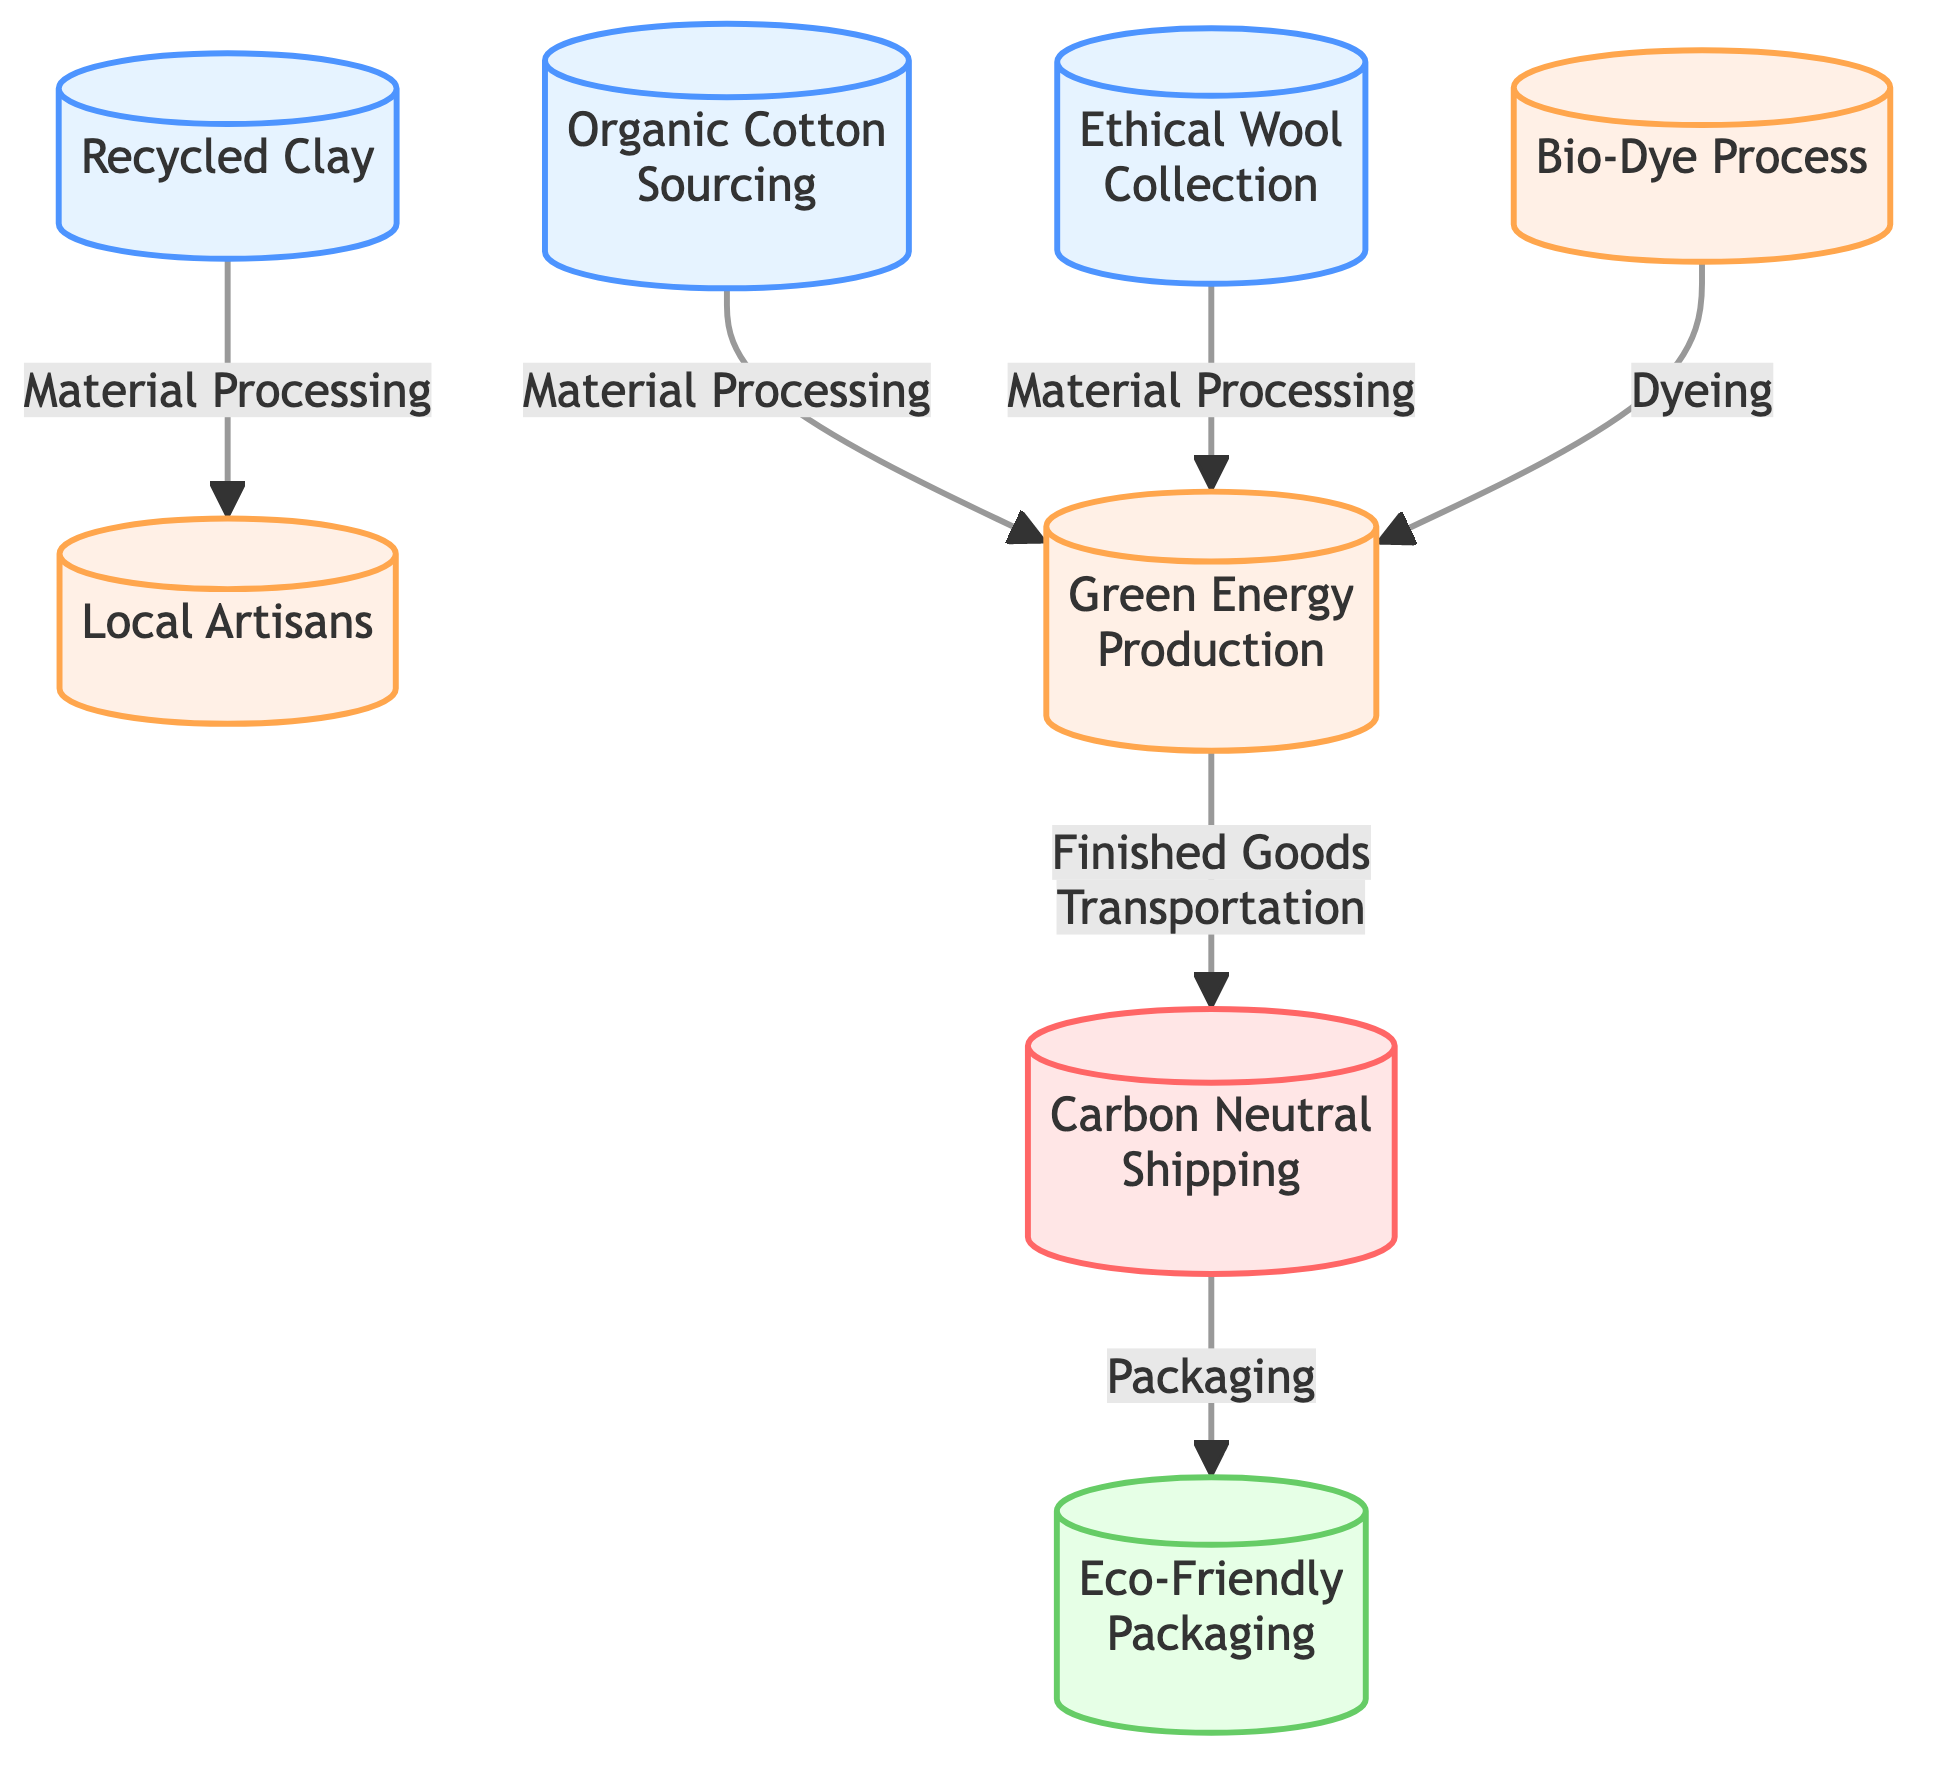What is the total number of nodes in the diagram? The diagram presents several distinct nodes, each representing a part of the process. By counting all unique nodes listed in the 'nodes' section, we find eight nodes total.
Answer: 8 Which material sourcing node is associated with recycled components? In the 'nodes' section, the "Recycled Clay" node explicitly identifies the use of recycled pottery materials in its description, making it the node related to recycled components.
Answer: Recycled Clay What type of energy is used in the manufacturing processes? The diagram indicates that the "Green Energy Production" node describes the use of renewable energy sources, which applies to multiple paths in the manufacturing process, highlighting the overall commitment to sustainable energy use.
Answer: Green Energy How many types of processes are indicated between nodes? The diagram includes three distinct types of processes represented by edges: 'Material Processing,' 'Dyeing,' and 'Finished Goods Transportation' that detail the transitions between nodes. Counting all types gives a total of three.
Answer: 3 What relationship connects the "Organic Cotton Sourcing" and "Green Energy Production" nodes? The connection between the "Organic Cotton Sourcing" node and "Green Energy Production" node is classified as "Material Processing," which means this specific process utilizes green energy for the preparation of organic cotton.
Answer: Material Processing Which node is linked to eco-friendly materials directly before packaging? The "Carbon Neutral Shipping" node directly connects to the "Eco-Friendly Packaging" node, indicating that after the shipping process, products are packaged using sustainable materials before they reach the consumer.
Answer: Carbon Neutral Shipping What type of packaging materials are mentioned in the diagram? The "Eco-Friendly Packaging" node specifies that the materials used are both recycled and biodegradable, indicating a conscientious choice for sustainable packaging solutions.
Answer: Recycled and biodegradable materials Which nodes utilize a bio-dye process? The "Bio-Dye Process" node is linked to both the "Organic Cotton Sourcing" and "Ethical Wool Collection" nodes, highlighting that this dyeing process applies to both types of organic materials within the diagram.
Answer: Organic Cotton Sourcing and Ethical Wool Collection 